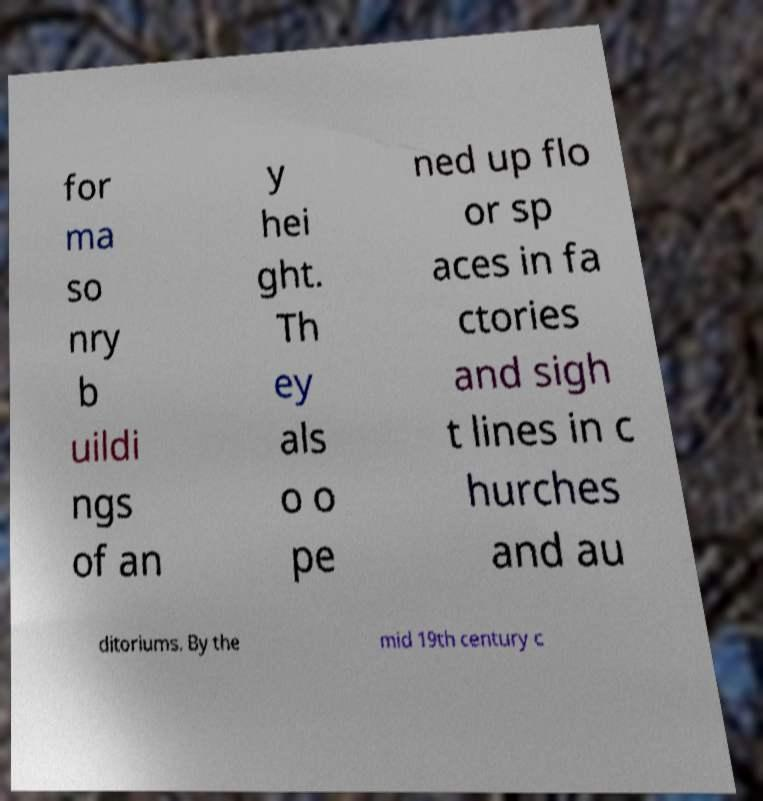Could you assist in decoding the text presented in this image and type it out clearly? for ma so nry b uildi ngs of an y hei ght. Th ey als o o pe ned up flo or sp aces in fa ctories and sigh t lines in c hurches and au ditoriums. By the mid 19th century c 